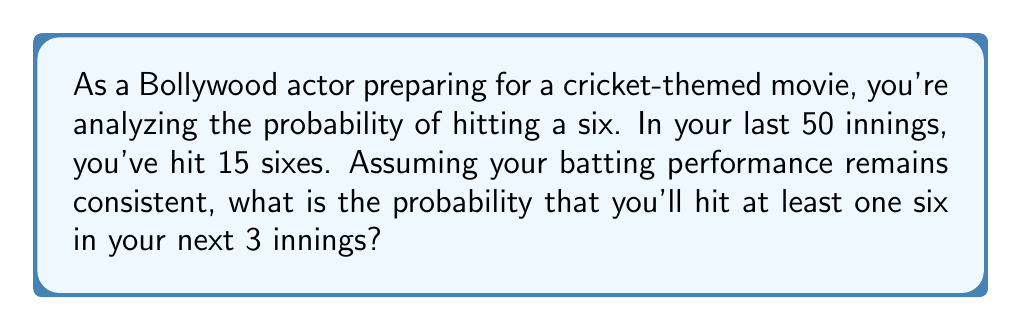Could you help me with this problem? Let's approach this step-by-step using discrete probability:

1) First, let's calculate the probability of hitting a six in a single inning:
   $P(\text{six}) = \frac{\text{number of sixes}}{\text{total innings}} = \frac{15}{50} = 0.3$

2) Therefore, the probability of not hitting a six in a single inning is:
   $P(\text{no six}) = 1 - P(\text{six}) = 1 - 0.3 = 0.7$

3) Now, we need to find the probability of not hitting a six in all 3 innings:
   $P(\text{no six in 3 innings}) = (0.7)^3 = 0.343$

4) The probability of hitting at least one six in 3 innings is the complement of this:
   $P(\text{at least one six in 3 innings}) = 1 - P(\text{no six in 3 innings})$
   $= 1 - 0.343 = 0.657$

5) We can also calculate this using the binomial probability formula:
   $$P(X \geq 1) = 1 - P(X = 0) = 1 - \binom{3}{0}(0.3)^0(0.7)^3 = 0.657$$

   Where $X$ is the number of sixes hit in 3 innings.
Answer: The probability of hitting at least one six in the next 3 innings is approximately 0.657 or 65.7%. 